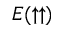Convert formula to latex. <formula><loc_0><loc_0><loc_500><loc_500>E ( \uparrow \uparrow )</formula> 